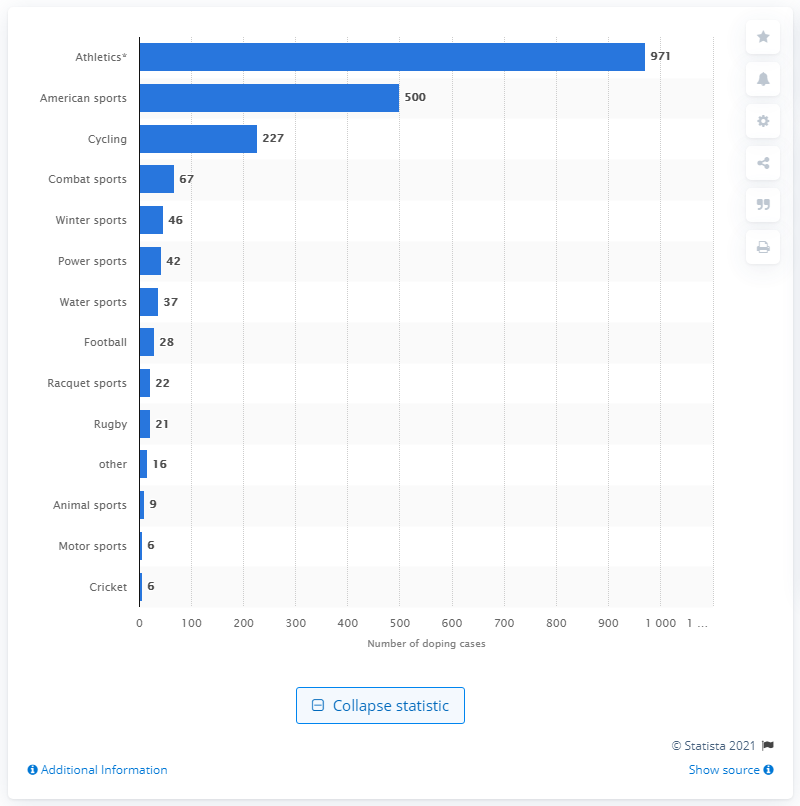Indicate a few pertinent items in this graphic. During the period of 2000 to 2010, a total of 227 doping cases were registered in cycling. 